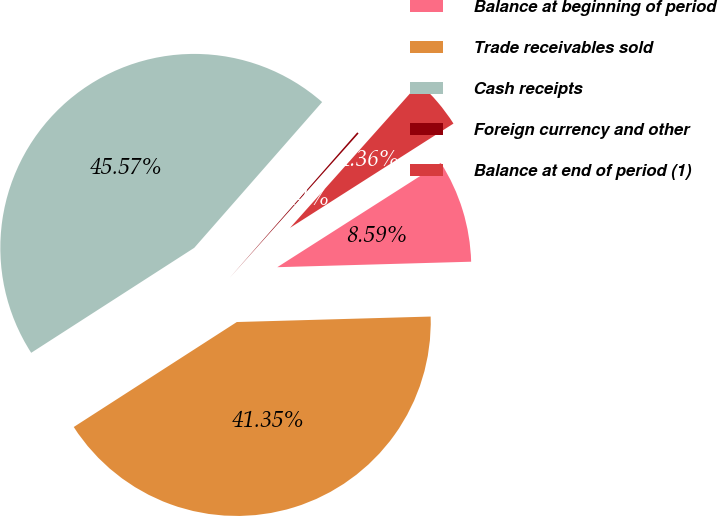Convert chart to OTSL. <chart><loc_0><loc_0><loc_500><loc_500><pie_chart><fcel>Balance at beginning of period<fcel>Trade receivables sold<fcel>Cash receipts<fcel>Foreign currency and other<fcel>Balance at end of period (1)<nl><fcel>8.59%<fcel>41.35%<fcel>45.57%<fcel>0.14%<fcel>4.36%<nl></chart> 